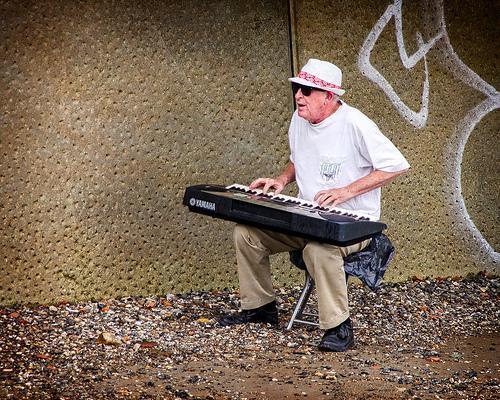How many hats are in this picture?
Give a very brief answer. 1. 